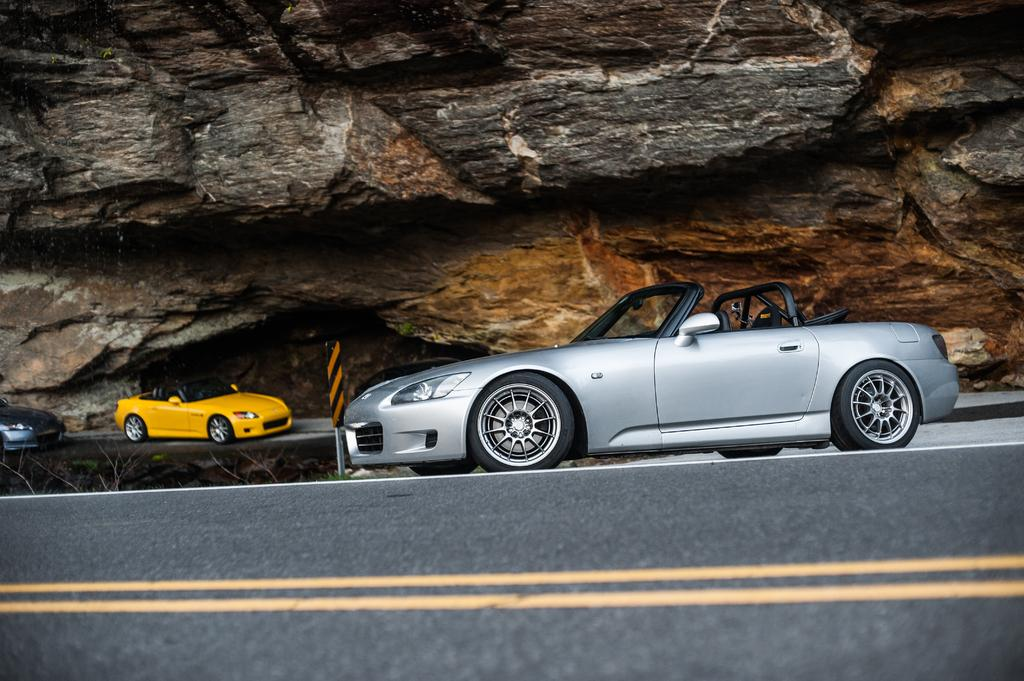What can be seen on the road in the image? There are cars on the road in the image. Where are the cars located in relation to the rock? The cars are under a rock in the image. What type of fuel is the pig using to wash the cars in the image? There is no pig or washing of cars present in the image. 